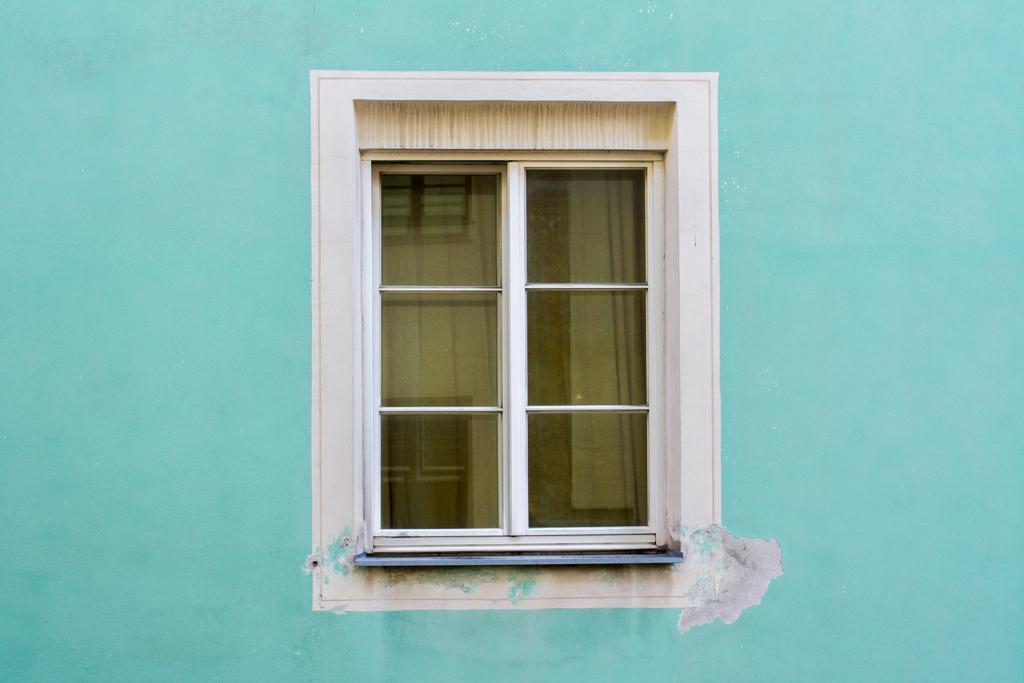How would you summarize this image in a sentence or two? In this image I can see blue wall and glass window. On the glass window there is a reflection of the windows.   